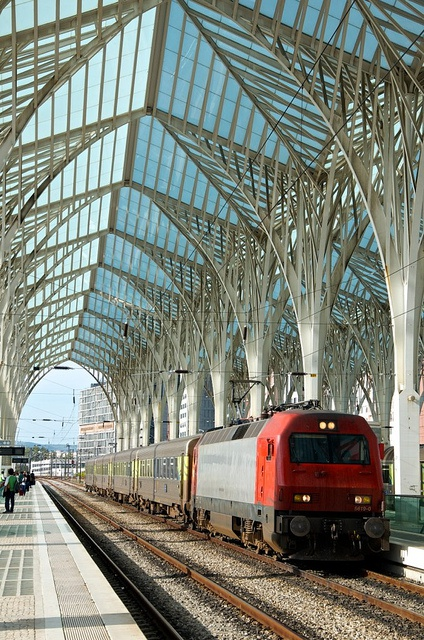Describe the objects in this image and their specific colors. I can see train in olive, black, maroon, darkgray, and lightgray tones, people in olive, black, darkgreen, gray, and darkgray tones, people in olive, black, gray, darkgray, and navy tones, people in black, gray, and olive tones, and people in olive, black, gray, and darkgreen tones in this image. 